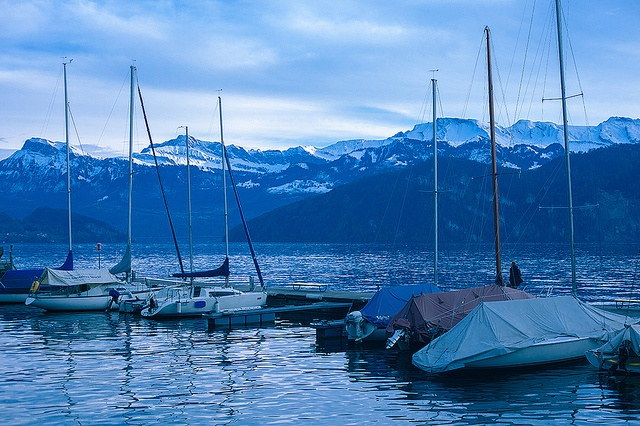Describe the objects in this image and their specific colors. I can see boat in lightblue, teal, navy, and gray tones, boat in lightblue, blue, darkgray, and lavender tones, boat in lightblue, navy, black, darkblue, and purple tones, boat in lightblue, blue, navy, and black tones, and boat in lightblue, blue, navy, darkblue, and darkgray tones in this image. 